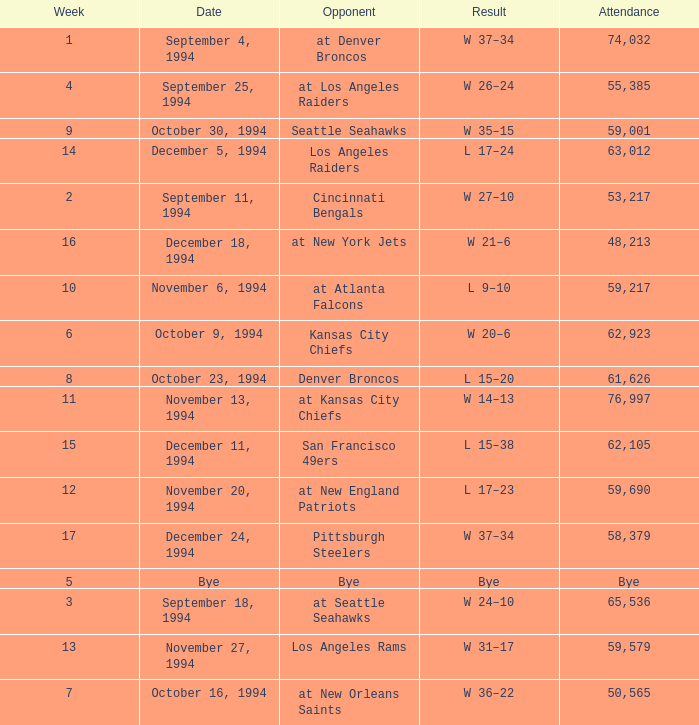In the game where they played the Pittsburgh Steelers, what was the attendance? 58379.0. 